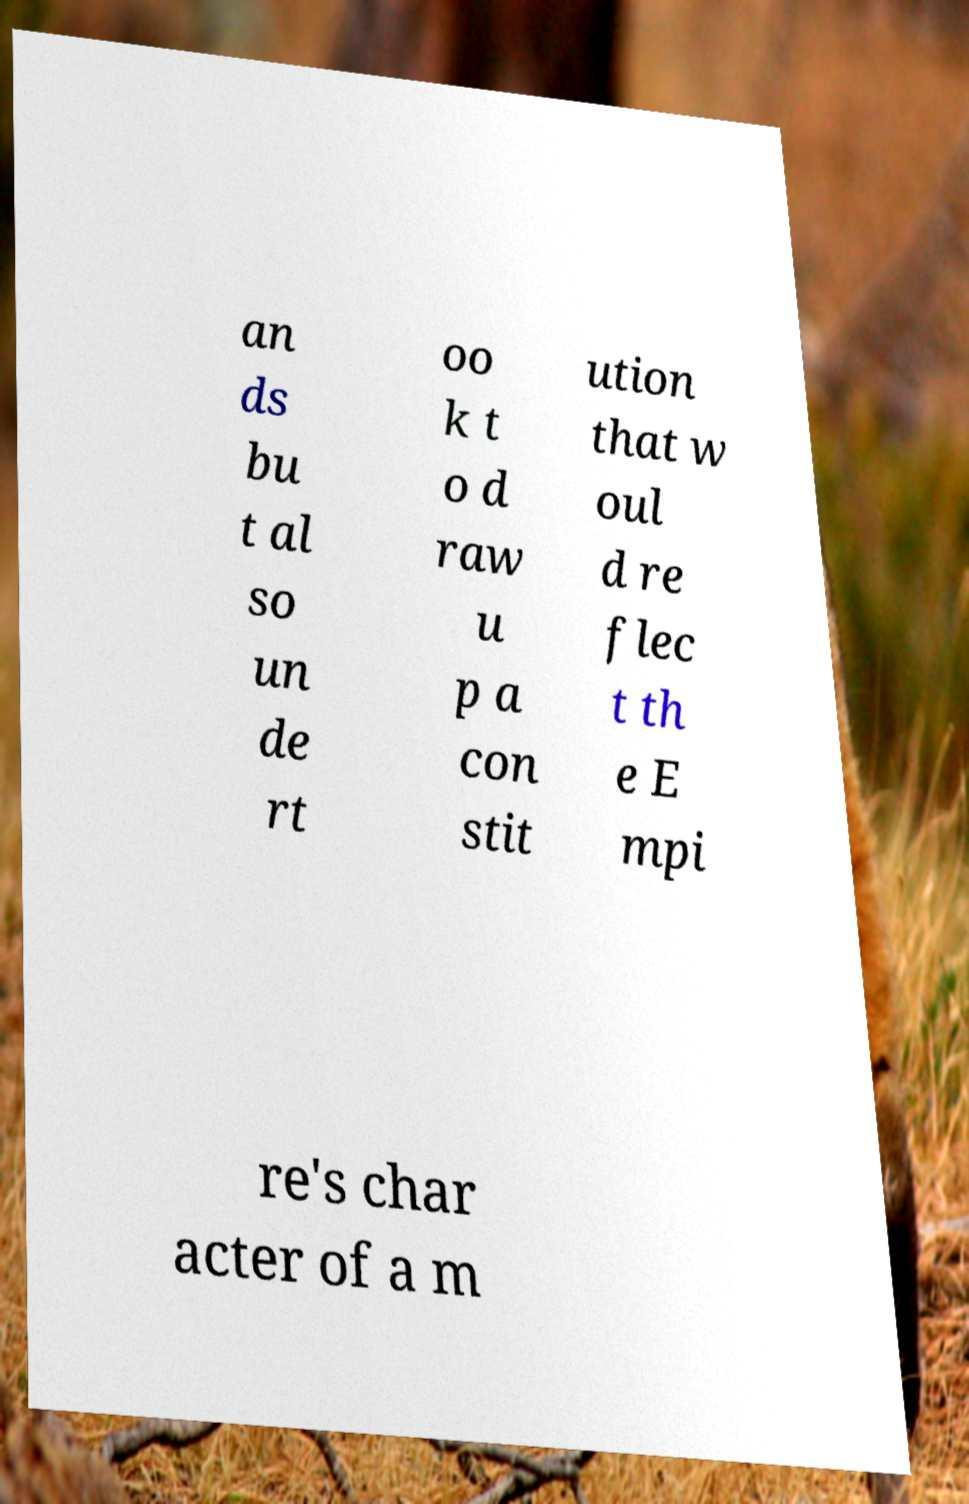For documentation purposes, I need the text within this image transcribed. Could you provide that? an ds bu t al so un de rt oo k t o d raw u p a con stit ution that w oul d re flec t th e E mpi re's char acter of a m 